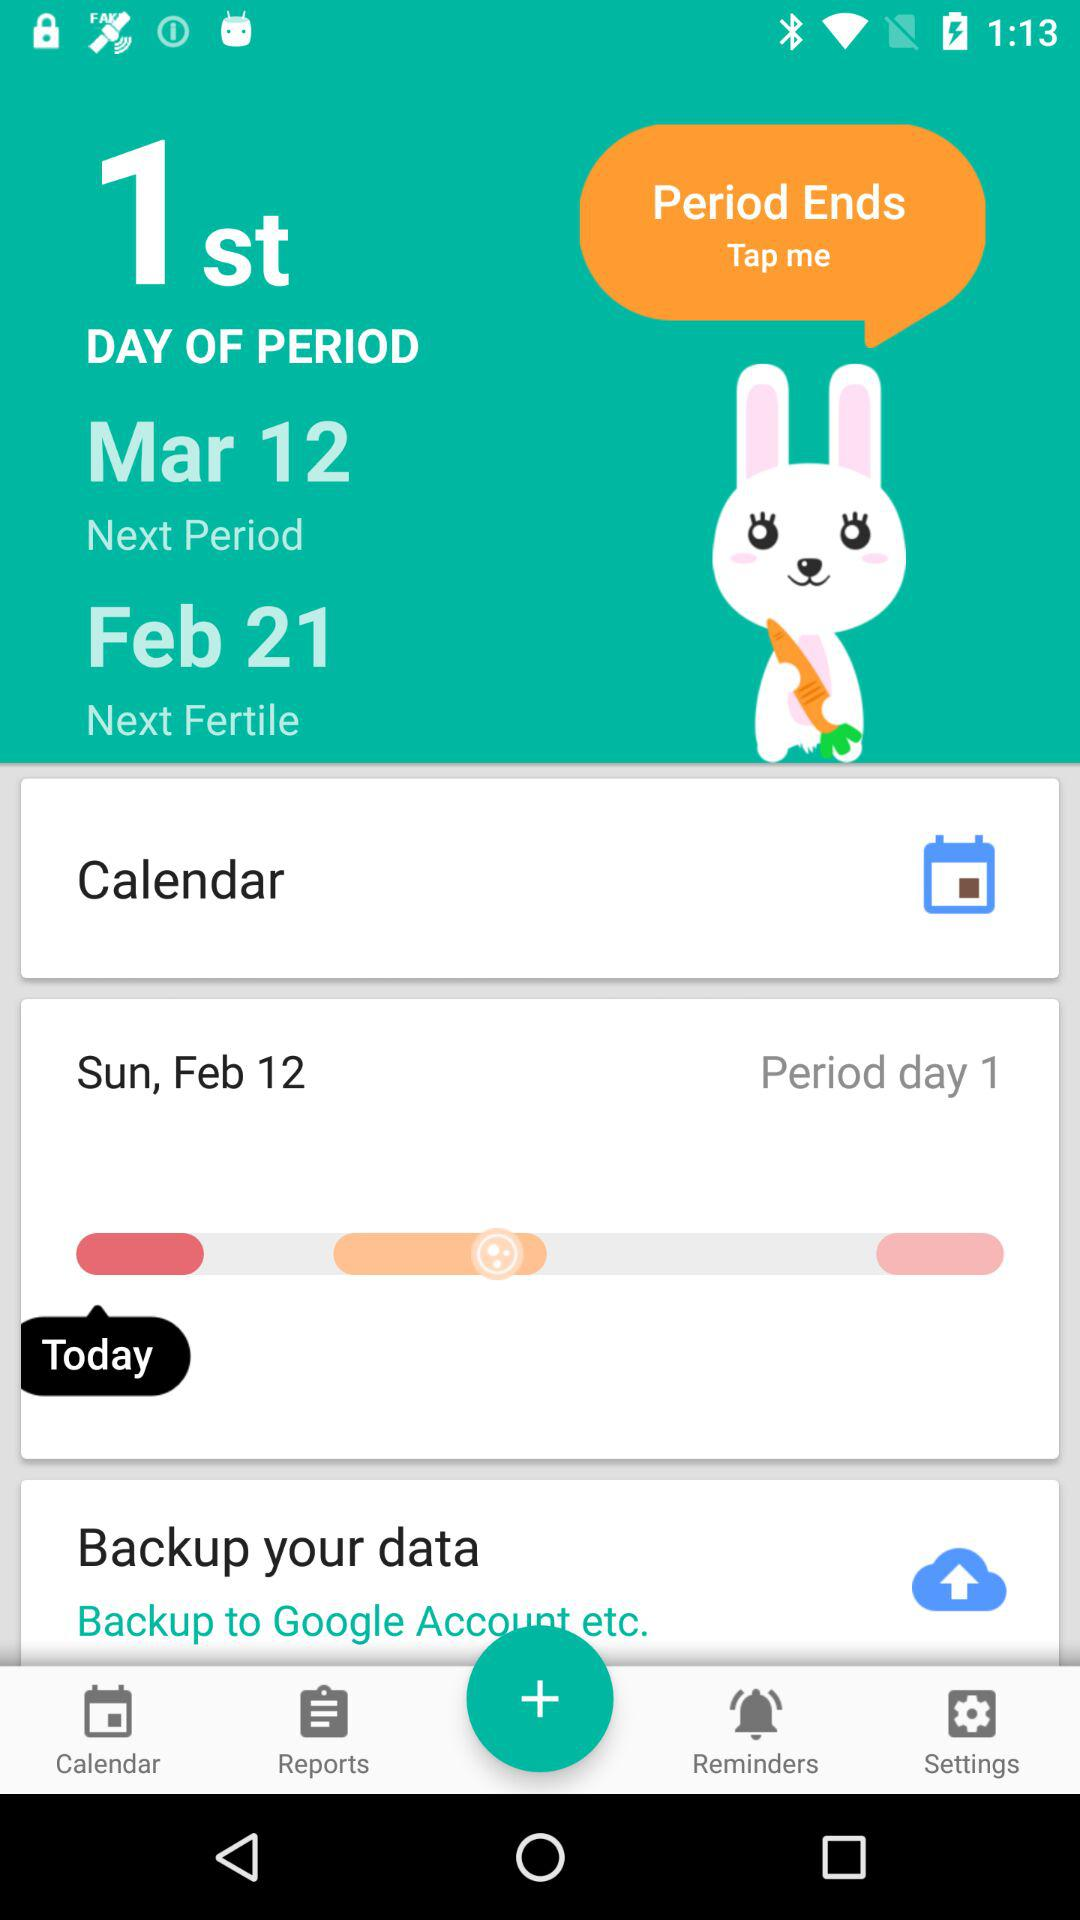What is the next fertile date? The next fertile date is February 21. 